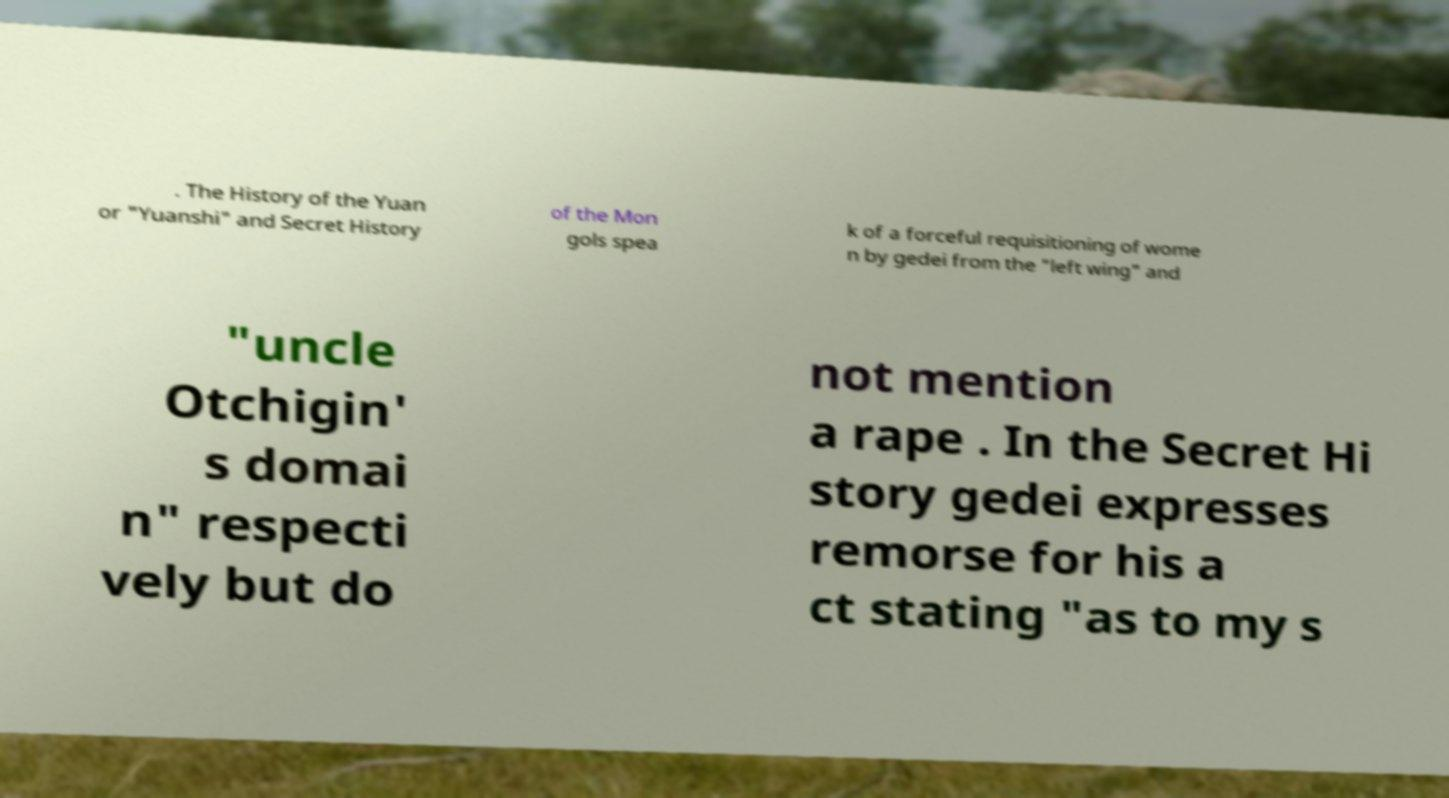What messages or text are displayed in this image? I need them in a readable, typed format. . The History of the Yuan or "Yuanshi" and Secret History of the Mon gols spea k of a forceful requisitioning of wome n by gedei from the "left wing" and "uncle Otchigin' s domai n" respecti vely but do not mention a rape . In the Secret Hi story gedei expresses remorse for his a ct stating "as to my s 